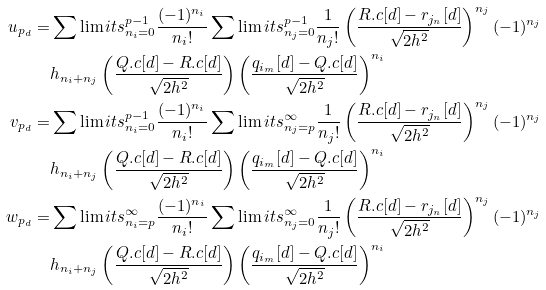Convert formula to latex. <formula><loc_0><loc_0><loc_500><loc_500>u _ { p _ { d } } = & \sum \lim i t s _ { n _ { i } = 0 } ^ { p - 1 } \frac { ( - 1 ) ^ { n _ { i } } } { n _ { i } ! } \sum \lim i t s _ { n _ { j } = 0 } ^ { p - 1 } \frac { 1 } { n _ { j } ! } \left ( \frac { R . c [ d ] - r _ { j _ { n } } [ d ] } { \sqrt { 2 h ^ { 2 } } } \right ) ^ { n _ { j } } ( - 1 ) ^ { n _ { j } } \\ & h _ { n _ { i } + n _ { j } } \left ( \frac { Q . c [ d ] - R . c [ d ] } { \sqrt { 2 h ^ { 2 } } } \right ) \left ( \frac { q _ { i _ { m } } [ d ] - Q . c [ d ] } { \sqrt { 2 h ^ { 2 } } } \right ) ^ { n _ { i } } \\ v _ { p _ { d } } = & \sum \lim i t s _ { n _ { i } = 0 } ^ { p - 1 } \frac { ( - 1 ) ^ { n _ { i } } } { n _ { i } ! } \sum \lim i t s _ { n _ { j } = p } ^ { \infty } \frac { 1 } { n _ { j } ! } \left ( \frac { R . c [ d ] - r _ { j _ { n } } [ d ] } { \sqrt { 2 h ^ { 2 } } } \right ) ^ { n _ { j } } ( - 1 ) ^ { n _ { j } } \\ & h _ { n _ { i } + n _ { j } } \left ( \frac { Q . c [ d ] - R . c [ d ] } { \sqrt { 2 h ^ { 2 } } } \right ) \left ( \frac { q _ { i _ { m } } [ d ] - Q . c [ d ] } { \sqrt { 2 h ^ { 2 } } } \right ) ^ { n _ { i } } \\ w _ { p _ { d } } = & \sum \lim i t s _ { n _ { i } = p } ^ { \infty } \frac { ( - 1 ) ^ { n _ { i } } } { n _ { i } ! } \sum \lim i t s _ { n _ { j } = 0 } ^ { \infty } \frac { 1 } { n _ { j } ! } \left ( \frac { R . c [ d ] - r _ { j _ { n } } [ d ] } { \sqrt { 2 h ^ { 2 } } } \right ) ^ { n _ { j } } ( - 1 ) ^ { n _ { j } } \\ & h _ { n _ { i } + n _ { j } } \left ( \frac { Q . c [ d ] - R . c [ d ] } { \sqrt { 2 h ^ { 2 } } } \right ) \left ( \frac { q _ { i _ { m } } [ d ] - Q . c [ d ] } { \sqrt { 2 h ^ { 2 } } } \right ) ^ { n _ { i } }</formula> 